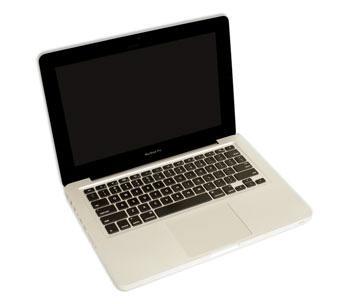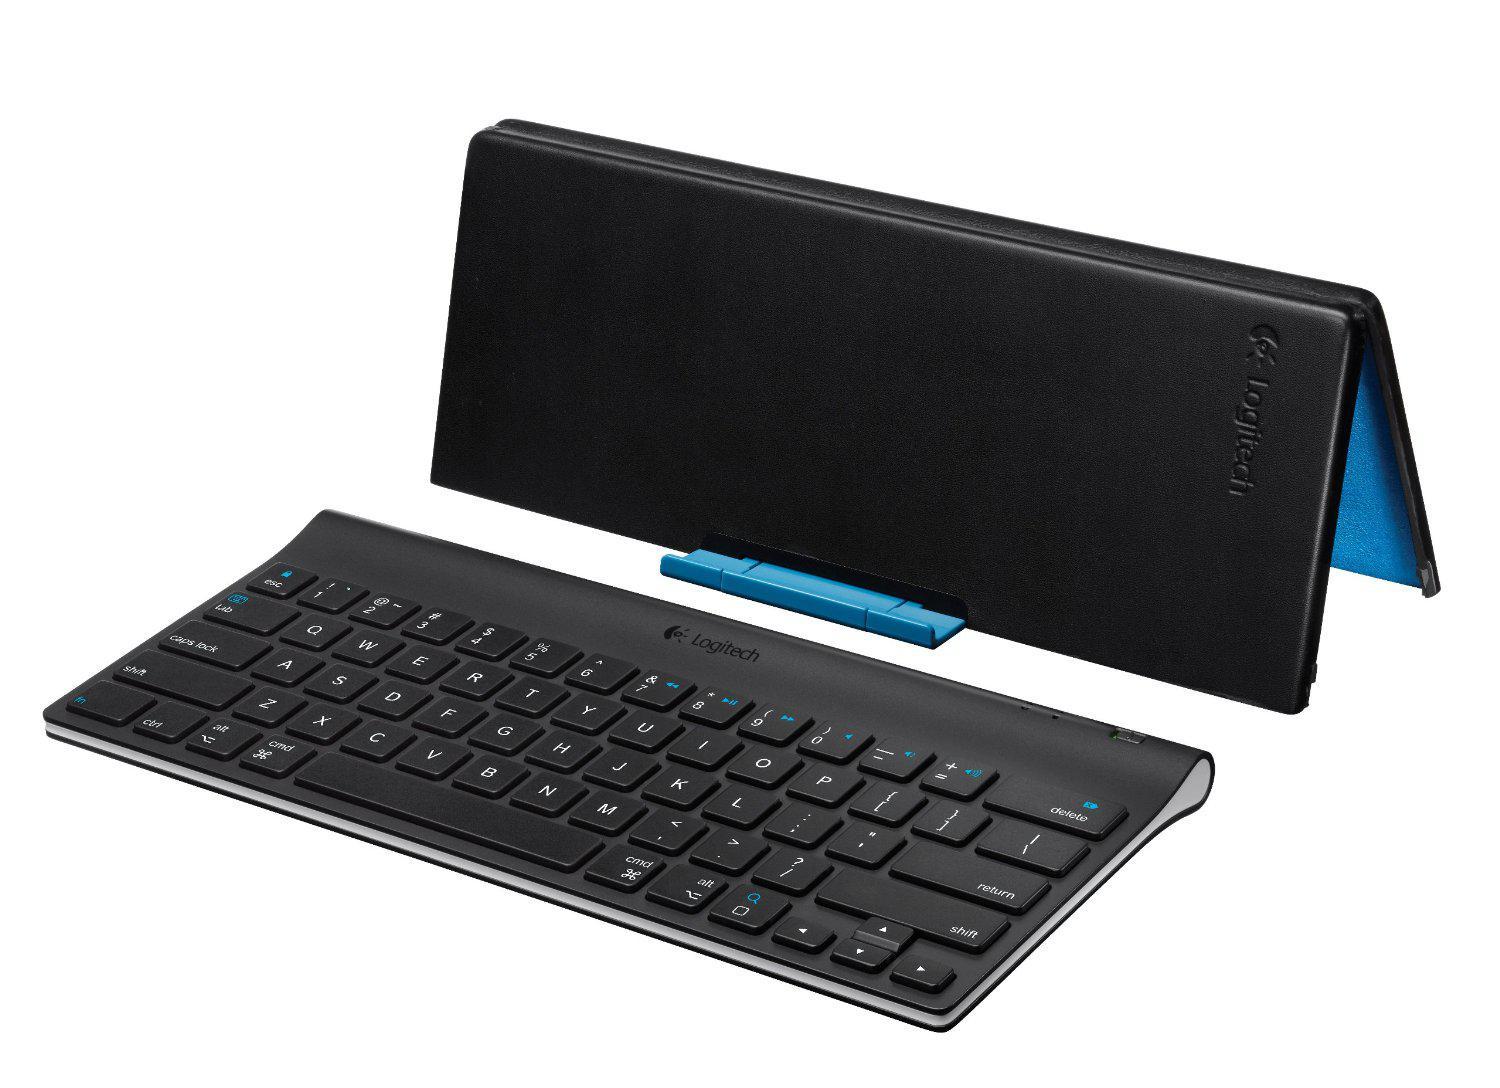The first image is the image on the left, the second image is the image on the right. Analyze the images presented: Is the assertion "The laptop in the image on the left is facing right." valid? Answer yes or no. Yes. 